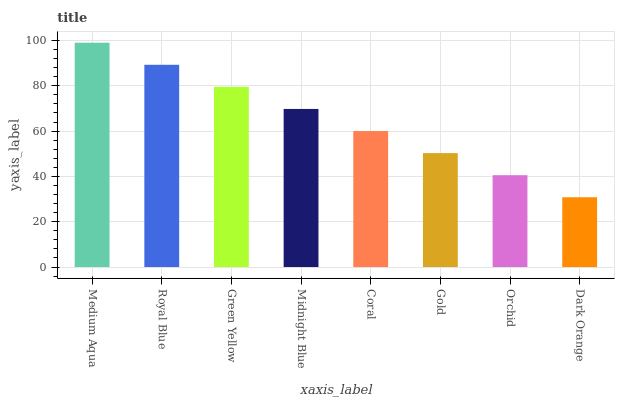Is Dark Orange the minimum?
Answer yes or no. Yes. Is Medium Aqua the maximum?
Answer yes or no. Yes. Is Royal Blue the minimum?
Answer yes or no. No. Is Royal Blue the maximum?
Answer yes or no. No. Is Medium Aqua greater than Royal Blue?
Answer yes or no. Yes. Is Royal Blue less than Medium Aqua?
Answer yes or no. Yes. Is Royal Blue greater than Medium Aqua?
Answer yes or no. No. Is Medium Aqua less than Royal Blue?
Answer yes or no. No. Is Midnight Blue the high median?
Answer yes or no. Yes. Is Coral the low median?
Answer yes or no. Yes. Is Orchid the high median?
Answer yes or no. No. Is Royal Blue the low median?
Answer yes or no. No. 